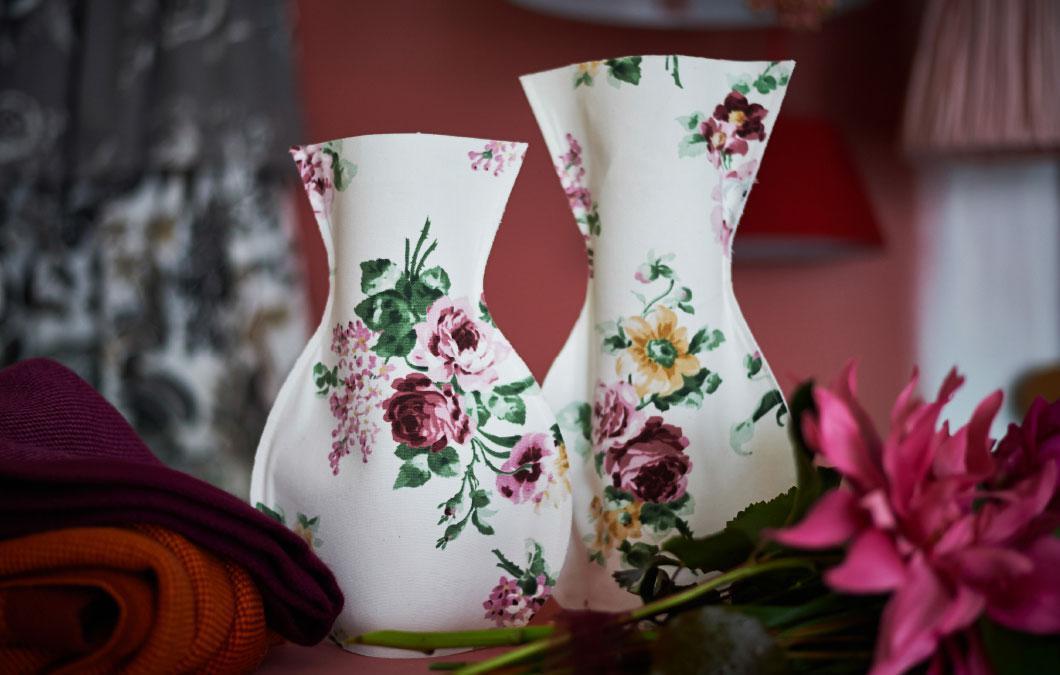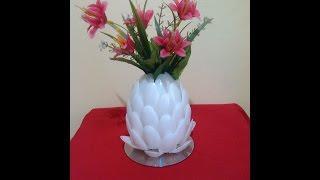The first image is the image on the left, the second image is the image on the right. Evaluate the accuracy of this statement regarding the images: "In one image the object rests on a tablecloth and in the other image it rests on bare wood.". Is it true? Answer yes or no. No. The first image is the image on the left, the second image is the image on the right. Analyze the images presented: Is the assertion "An image shows a white vase resembling an artichoke, filled with red lily-type flowers and sitting on a table." valid? Answer yes or no. Yes. 